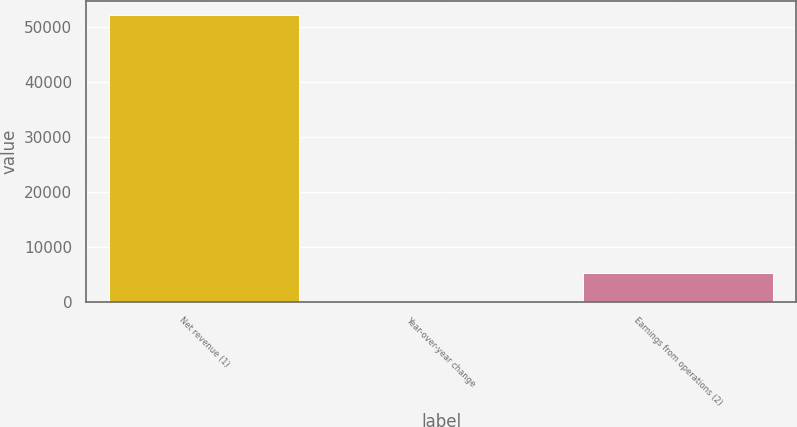Convert chart. <chart><loc_0><loc_0><loc_500><loc_500><bar_chart><fcel>Net revenue (1)<fcel>Year-over-year change<fcel>Earnings from operations (2)<nl><fcel>52107<fcel>5.5<fcel>5215.65<nl></chart> 